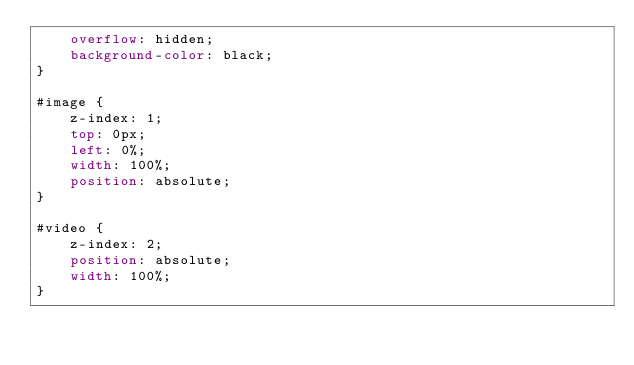<code> <loc_0><loc_0><loc_500><loc_500><_CSS_>    overflow: hidden;
    background-color: black;
}

#image {
    z-index: 1;
    top: 0px;
    left: 0%;
    width: 100%;
    position: absolute;
}

#video {
    z-index: 2;
    position: absolute;
    width: 100%;
}
</code> 